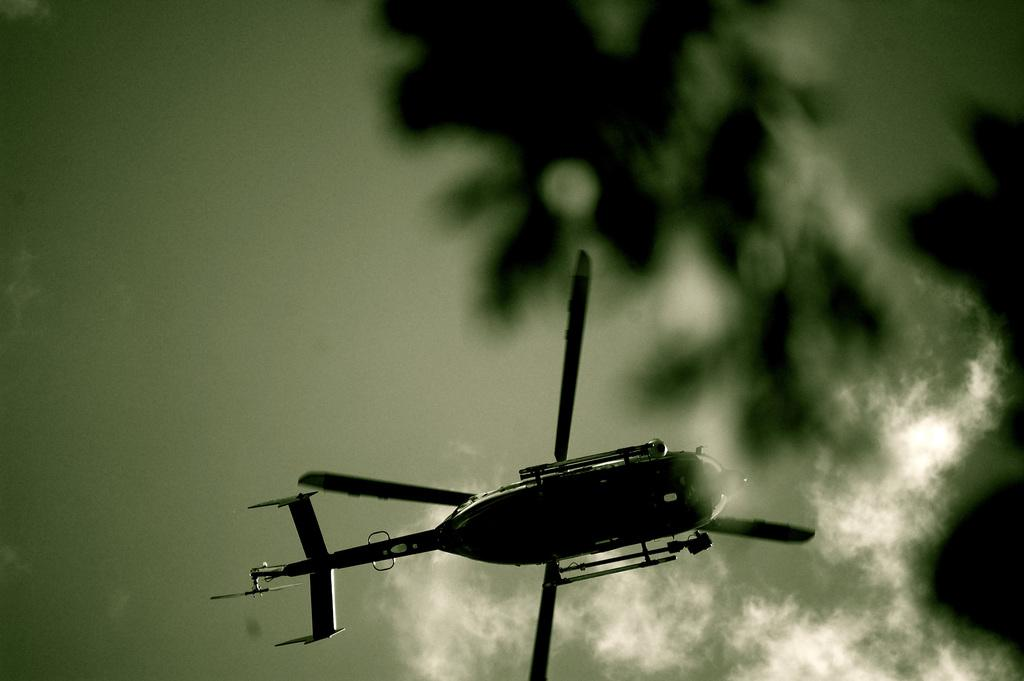What is the main subject of the image? The main subject of the image is a helicopter. What is the helicopter doing in the image? The helicopter is flying in the image. What can be seen in the background of the image? There is sky visible in the image, and clouds are present in the sky. Can you see any feathers falling from the helicopter in the image? There are no feathers present in the image, and they are not associated with helicopters. 